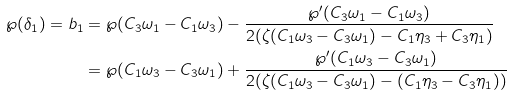Convert formula to latex. <formula><loc_0><loc_0><loc_500><loc_500>\wp ( \delta _ { 1 } ) = b _ { 1 } & = \wp ( C _ { 3 } \omega _ { 1 } - C _ { 1 } \omega _ { 3 } ) - \frac { \wp ^ { \prime } ( C _ { 3 } \omega _ { 1 } - C _ { 1 } \omega _ { 3 } ) } { 2 ( \zeta ( C _ { 1 } \omega _ { 3 } - C _ { 3 } \omega _ { 1 } ) - C _ { 1 } \eta _ { 3 } + C _ { 3 } \eta _ { 1 } ) } \\ & = \wp ( C _ { 1 } \omega _ { 3 } - C _ { 3 } \omega _ { 1 } ) + \frac { \wp ^ { \prime } ( C _ { 1 } \omega _ { 3 } - C _ { 3 } \omega _ { 1 } ) } { 2 ( \zeta ( C _ { 1 } \omega _ { 3 } - C _ { 3 } \omega _ { 1 } ) - ( C _ { 1 } \eta _ { 3 } - C _ { 3 } \eta _ { 1 } ) ) }</formula> 